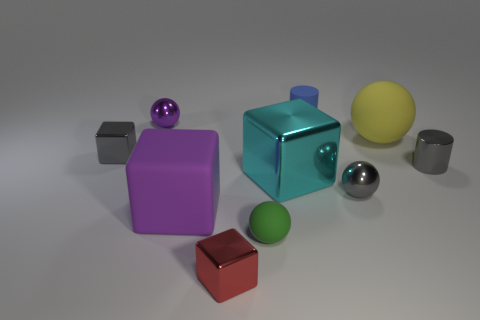The cyan metallic thing that is the same size as the yellow object is what shape?
Offer a terse response. Cube. There is a big rubber thing that is behind the gray metal thing to the left of the small purple thing; what number of large cubes are behind it?
Your answer should be compact. 0. Are there more small spheres that are on the left side of the red metal block than gray spheres to the left of the rubber cylinder?
Keep it short and to the point. Yes. How many other small objects are the same shape as the blue object?
Your answer should be compact. 1. What number of objects are cubes that are on the left side of the purple metallic sphere or shiny things that are in front of the large yellow sphere?
Keep it short and to the point. 5. What is the material of the gray object that is right of the matte thing on the right side of the tiny blue thing that is behind the small gray ball?
Offer a very short reply. Metal. There is a tiny ball on the right side of the small green rubber thing; does it have the same color as the metallic cylinder?
Offer a terse response. Yes. What material is the tiny sphere that is both in front of the large yellow rubber thing and to the left of the cyan block?
Offer a very short reply. Rubber. Is there a yellow matte cube of the same size as the yellow rubber ball?
Provide a short and direct response. No. How many tiny gray balls are there?
Ensure brevity in your answer.  1. 